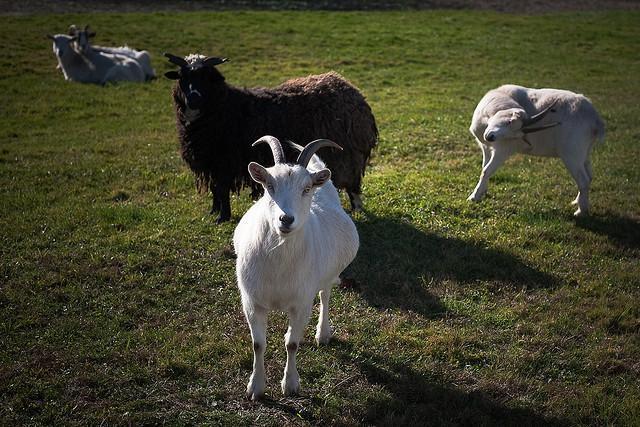How many sheep are in the photo?
Give a very brief answer. 4. 